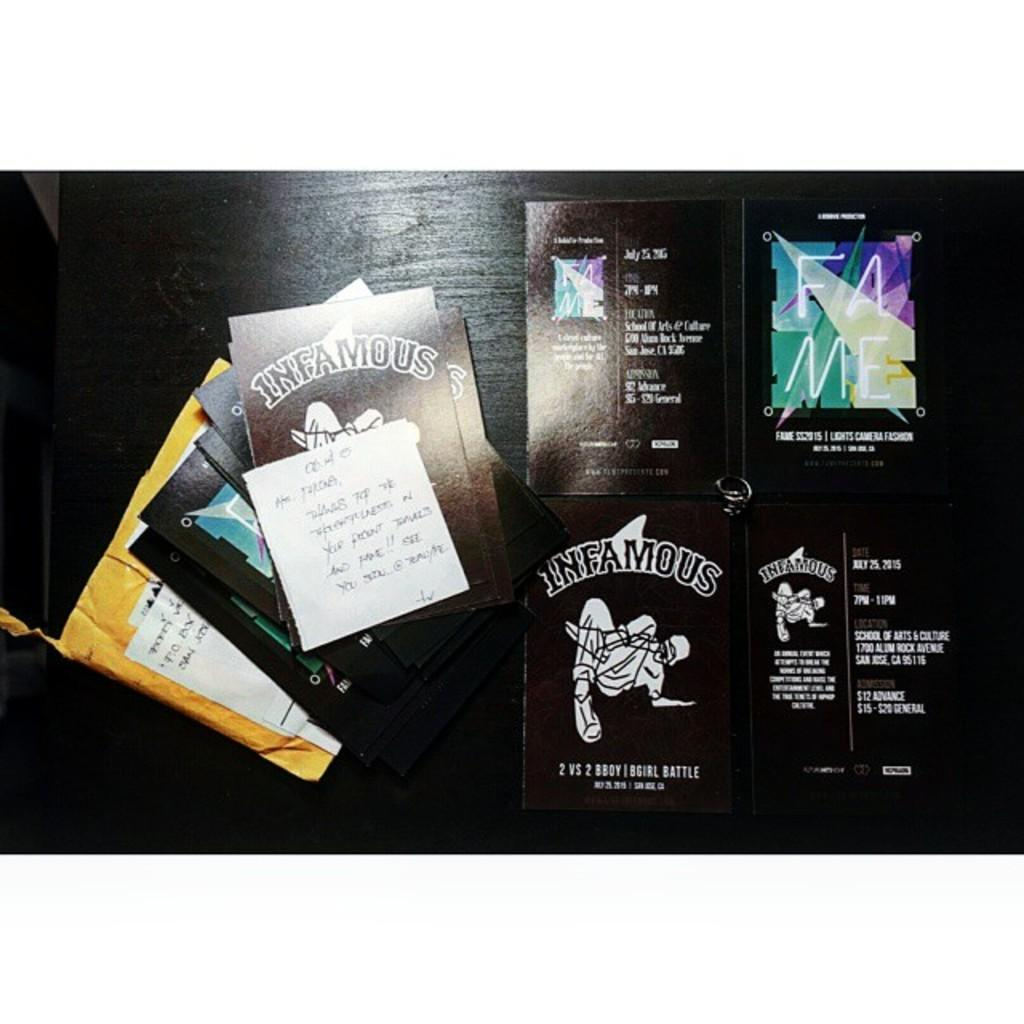Provide a one-sentence caption for the provided image. Brown colored cards by Infamous sit in piles on a surface. 